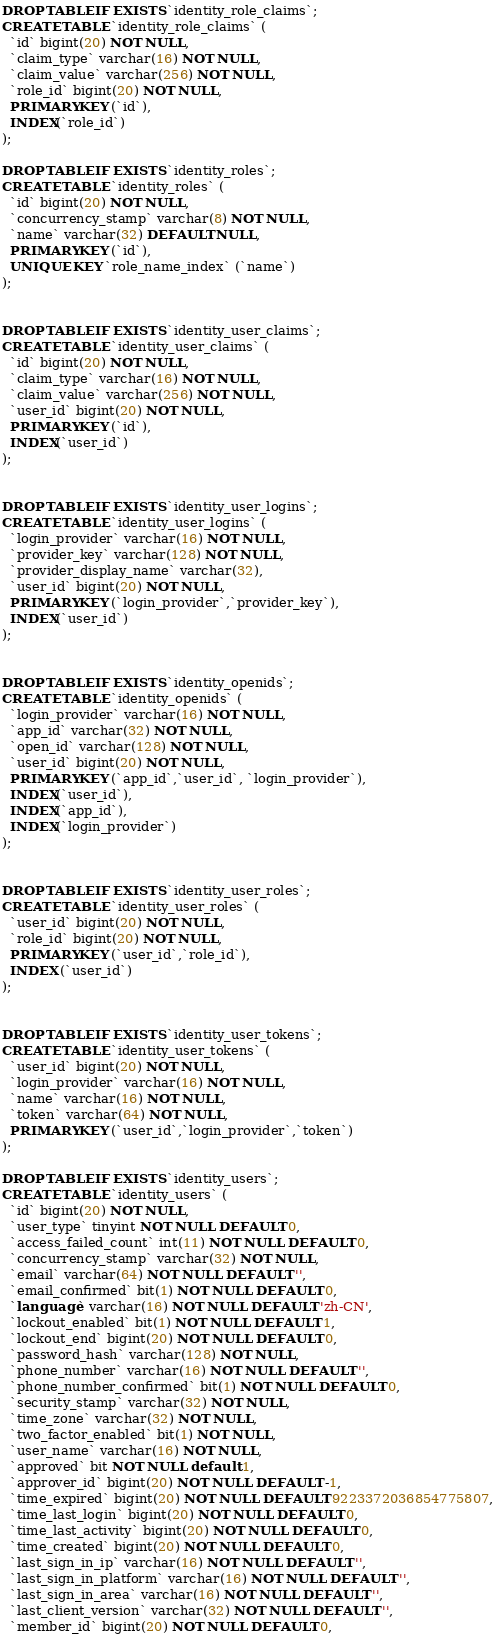<code> <loc_0><loc_0><loc_500><loc_500><_SQL_>

DROP TABLE IF EXISTS `identity_role_claims`;
CREATE TABLE `identity_role_claims` (
  `id` bigint(20) NOT NULL,
  `claim_type` varchar(16) NOT NULL,
  `claim_value` varchar(256) NOT NULL,
  `role_id` bigint(20) NOT NULL,
  PRIMARY KEY (`id`),
  INDEX(`role_id`)
);

DROP TABLE IF EXISTS `identity_roles`;
CREATE TABLE `identity_roles` (
  `id` bigint(20) NOT NULL,
  `concurrency_stamp` varchar(8) NOT NULL,
  `name` varchar(32) DEFAULT NULL,
  PRIMARY KEY (`id`),
  UNIQUE KEY `role_name_index` (`name`)
);


DROP TABLE IF EXISTS `identity_user_claims`;
CREATE TABLE `identity_user_claims` (
  `id` bigint(20) NOT NULL,
  `claim_type` varchar(16) NOT NULL,
  `claim_value` varchar(256) NOT NULL,
  `user_id` bigint(20) NOT NULL,
  PRIMARY KEY (`id`),
  INDEX(`user_id`)
);


DROP TABLE IF EXISTS `identity_user_logins`;
CREATE TABLE `identity_user_logins` (
  `login_provider` varchar(16) NOT NULL,
  `provider_key` varchar(128) NOT NULL,
  `provider_display_name` varchar(32),
  `user_id` bigint(20) NOT NULL,
  PRIMARY KEY (`login_provider`,`provider_key`),
  INDEX(`user_id`)
);


DROP TABLE IF EXISTS `identity_openids`;
CREATE TABLE `identity_openids` (
  `login_provider` varchar(16) NOT NULL,
  `app_id` varchar(32) NOT NULL,
  `open_id` varchar(128) NOT NULL,
  `user_id` bigint(20) NOT NULL,
  PRIMARY KEY (`app_id`,`user_id`, `login_provider`),
  INDEX(`user_id`),
  INDEX(`app_id`),
  INDEX(`login_provider`)
);


DROP TABLE IF EXISTS `identity_user_roles`;
CREATE TABLE `identity_user_roles` (
  `user_id` bigint(20) NOT NULL,
  `role_id` bigint(20) NOT NULL,
  PRIMARY KEY (`user_id`,`role_id`),
  INDEX (`user_id`)
);


DROP TABLE IF EXISTS `identity_user_tokens`;
CREATE TABLE `identity_user_tokens` (
  `user_id` bigint(20) NOT NULL,
  `login_provider` varchar(16) NOT NULL,
  `name` varchar(16) NOT NULL,
  `token` varchar(64) NOT NULL,
  PRIMARY KEY (`user_id`,`login_provider`,`token`)
);

DROP TABLE IF EXISTS `identity_users`;
CREATE TABLE `identity_users` (
  `id` bigint(20) NOT NULL,
  `user_type` tinyint NOT NULL DEFAULT 0,
  `access_failed_count` int(11) NOT NULL DEFAULT 0,
  `concurrency_stamp` varchar(32) NOT NULL,
  `email` varchar(64) NOT NULL DEFAULT '',
  `email_confirmed` bit(1) NOT NULL DEFAULT 0,
  `language` varchar(16) NOT NULL DEFAULT 'zh-CN',
  `lockout_enabled` bit(1) NOT NULL DEFAULT 1,
  `lockout_end` bigint(20) NOT NULL DEFAULT 0,
  `password_hash` varchar(128) NOT NULL,
  `phone_number` varchar(16) NOT NULL DEFAULT '',
  `phone_number_confirmed` bit(1) NOT NULL DEFAULT 0,
  `security_stamp` varchar(32) NOT NULL,
  `time_zone` varchar(32) NOT NULL,
  `two_factor_enabled` bit(1) NOT NULL,
  `user_name` varchar(16) NOT NULL,
  `approved` bit NOT NULL default 1,
  `approver_id` bigint(20) NOT NULL DEFAULT -1,
  `time_expired` bigint(20) NOT NULL DEFAULT 9223372036854775807,
  `time_last_login` bigint(20) NOT NULL DEFAULT 0,
  `time_last_activity` bigint(20) NOT NULL DEFAULT 0,
  `time_created` bigint(20) NOT NULL DEFAULT 0,
  `last_sign_in_ip` varchar(16) NOT NULL DEFAULT '',
  `last_sign_in_platform` varchar(16) NOT NULL DEFAULT '',
  `last_sign_in_area` varchar(16) NOT NULL DEFAULT '',
  `last_client_version` varchar(32) NOT NULL DEFAULT '',
  `member_id` bigint(20) NOT NULL DEFAULT 0,</code> 